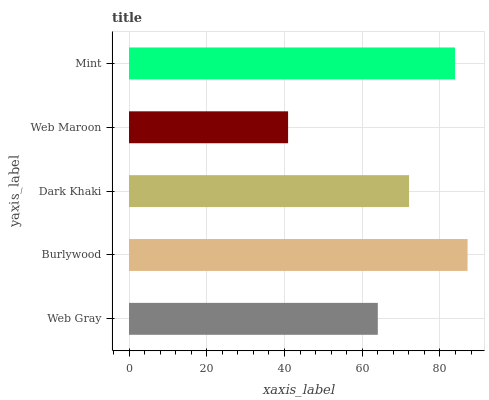Is Web Maroon the minimum?
Answer yes or no. Yes. Is Burlywood the maximum?
Answer yes or no. Yes. Is Dark Khaki the minimum?
Answer yes or no. No. Is Dark Khaki the maximum?
Answer yes or no. No. Is Burlywood greater than Dark Khaki?
Answer yes or no. Yes. Is Dark Khaki less than Burlywood?
Answer yes or no. Yes. Is Dark Khaki greater than Burlywood?
Answer yes or no. No. Is Burlywood less than Dark Khaki?
Answer yes or no. No. Is Dark Khaki the high median?
Answer yes or no. Yes. Is Dark Khaki the low median?
Answer yes or no. Yes. Is Web Maroon the high median?
Answer yes or no. No. Is Web Maroon the low median?
Answer yes or no. No. 